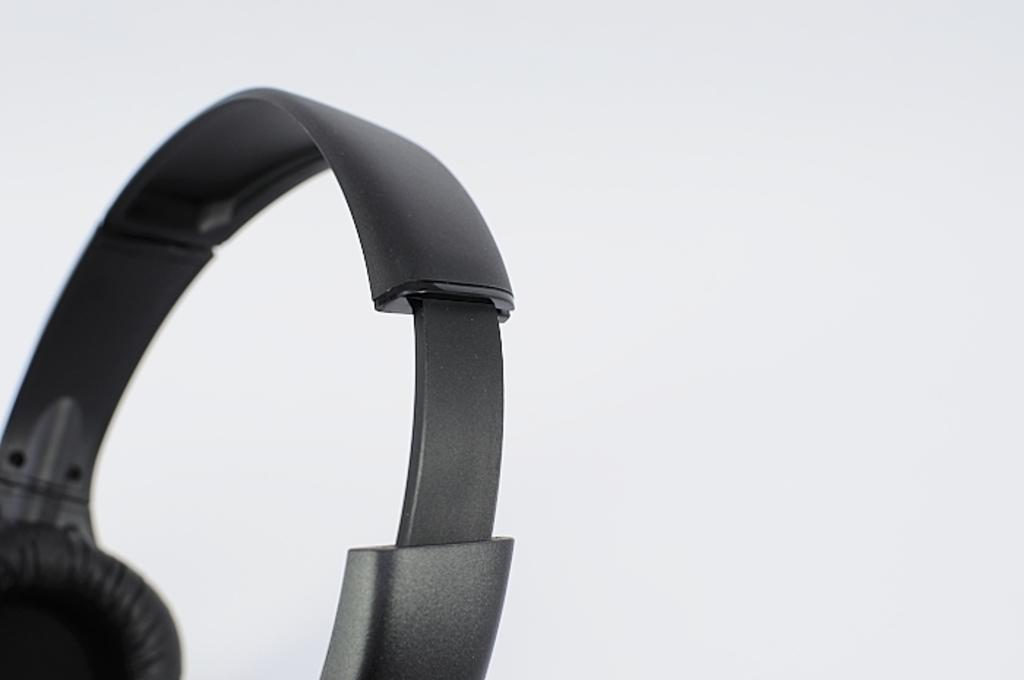What is the main object in the image? There is a headphone in the image. What color is the background of the image? The background of the image is white. Can you see a kettle pouring honey in the image? No, there is no kettle or honey present in the image. The image only features a headphone and a white background. 